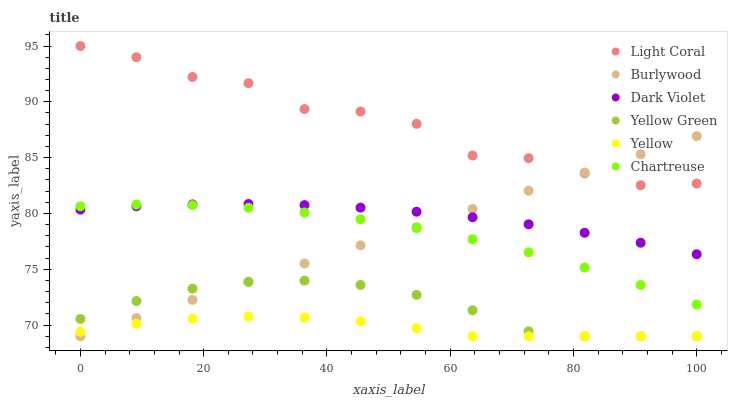Does Yellow have the minimum area under the curve?
Answer yes or no. Yes. Does Light Coral have the maximum area under the curve?
Answer yes or no. Yes. Does Burlywood have the minimum area under the curve?
Answer yes or no. No. Does Burlywood have the maximum area under the curve?
Answer yes or no. No. Is Burlywood the smoothest?
Answer yes or no. Yes. Is Light Coral the roughest?
Answer yes or no. Yes. Is Yellow the smoothest?
Answer yes or no. No. Is Yellow the roughest?
Answer yes or no. No. Does Yellow Green have the lowest value?
Answer yes or no. Yes. Does Light Coral have the lowest value?
Answer yes or no. No. Does Light Coral have the highest value?
Answer yes or no. Yes. Does Burlywood have the highest value?
Answer yes or no. No. Is Yellow Green less than Chartreuse?
Answer yes or no. Yes. Is Light Coral greater than Chartreuse?
Answer yes or no. Yes. Does Burlywood intersect Yellow Green?
Answer yes or no. Yes. Is Burlywood less than Yellow Green?
Answer yes or no. No. Is Burlywood greater than Yellow Green?
Answer yes or no. No. Does Yellow Green intersect Chartreuse?
Answer yes or no. No. 